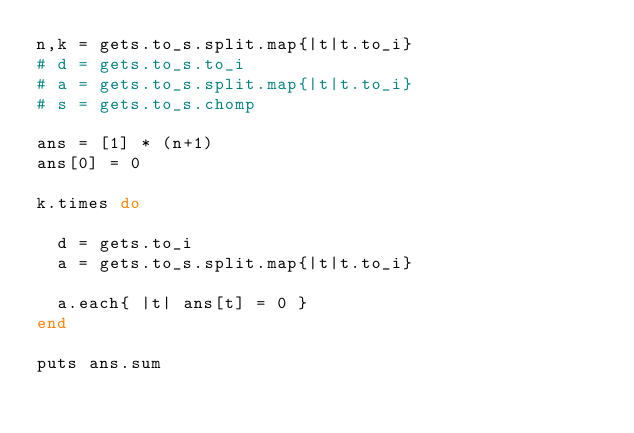Convert code to text. <code><loc_0><loc_0><loc_500><loc_500><_Ruby_>n,k = gets.to_s.split.map{|t|t.to_i}
# d = gets.to_s.to_i
# a = gets.to_s.split.map{|t|t.to_i}
# s = gets.to_s.chomp

ans = [1] * (n+1)
ans[0] = 0

k.times do
  
  d = gets.to_i
  a = gets.to_s.split.map{|t|t.to_i}
  
  a.each{ |t| ans[t] = 0 }
end

puts ans.sum</code> 